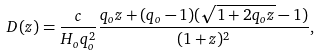<formula> <loc_0><loc_0><loc_500><loc_500>D ( z ) = \frac { c } { H _ { o } q _ { o } ^ { 2 } } \frac { q _ { o } z + ( q _ { o } - 1 ) ( \sqrt { 1 + 2 q _ { o } z } - 1 ) } { ( 1 + z ) ^ { 2 } } ,</formula> 